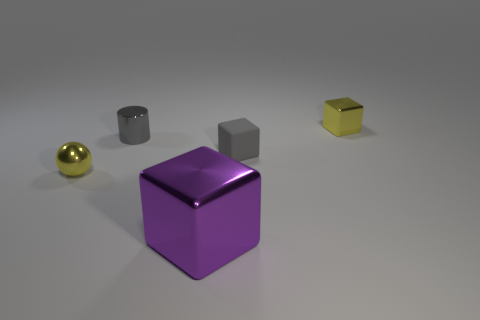What shape is the tiny yellow metallic thing that is behind the tiny yellow thing that is on the left side of the small gray shiny cylinder?
Ensure brevity in your answer.  Cube. How many gray rubber things are the same size as the purple metal block?
Your answer should be very brief. 0. Is there a big brown matte object?
Make the answer very short. No. Is there anything else of the same color as the large thing?
Ensure brevity in your answer.  No. What shape is the gray thing that is the same material as the big purple block?
Offer a very short reply. Cylinder. The metallic block that is in front of the small gray matte thing that is in front of the yellow metal object that is behind the small yellow shiny sphere is what color?
Your answer should be compact. Purple. Are there the same number of small gray metal cylinders that are to the right of the small rubber cube and large red spheres?
Offer a very short reply. Yes. Is there anything else that is made of the same material as the gray cube?
Offer a very short reply. No. There is a matte thing; does it have the same color as the tiny cylinder left of the large cube?
Offer a terse response. Yes. Are there any tiny things behind the tiny yellow cube that is behind the tiny yellow thing left of the gray rubber object?
Offer a very short reply. No. 